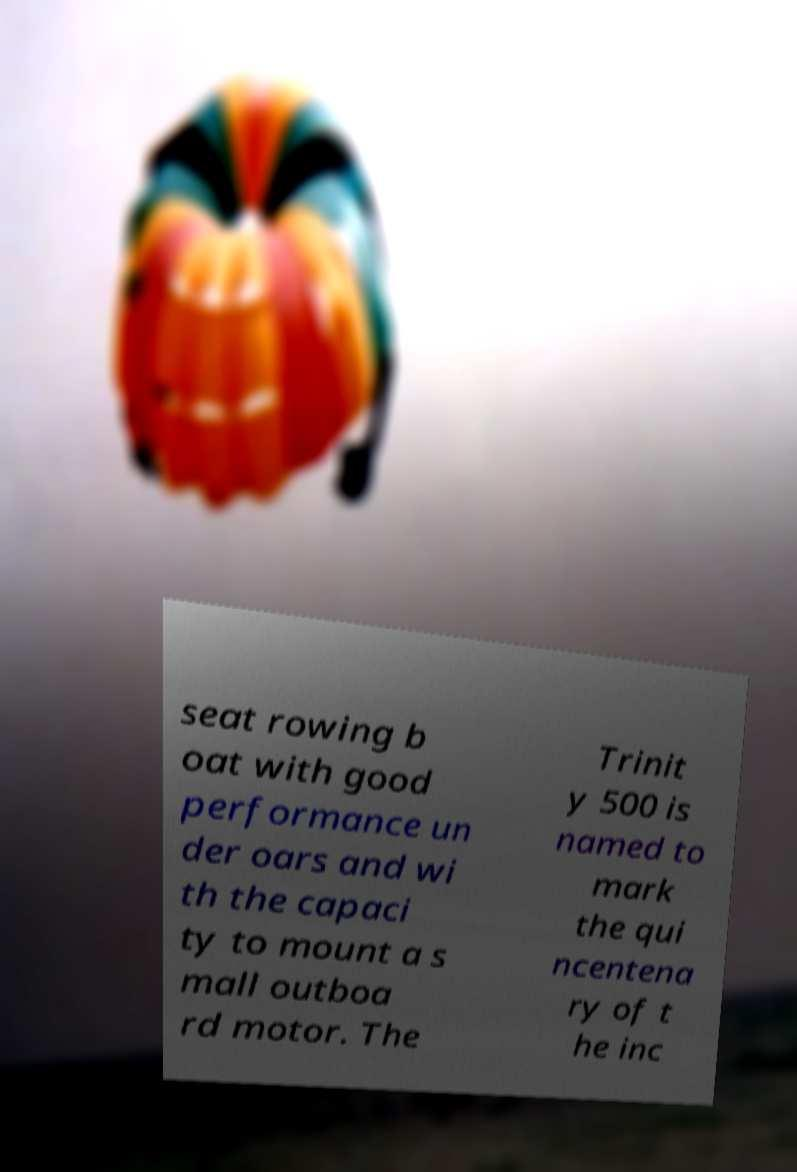Could you extract and type out the text from this image? seat rowing b oat with good performance un der oars and wi th the capaci ty to mount a s mall outboa rd motor. The Trinit y 500 is named to mark the qui ncentena ry of t he inc 